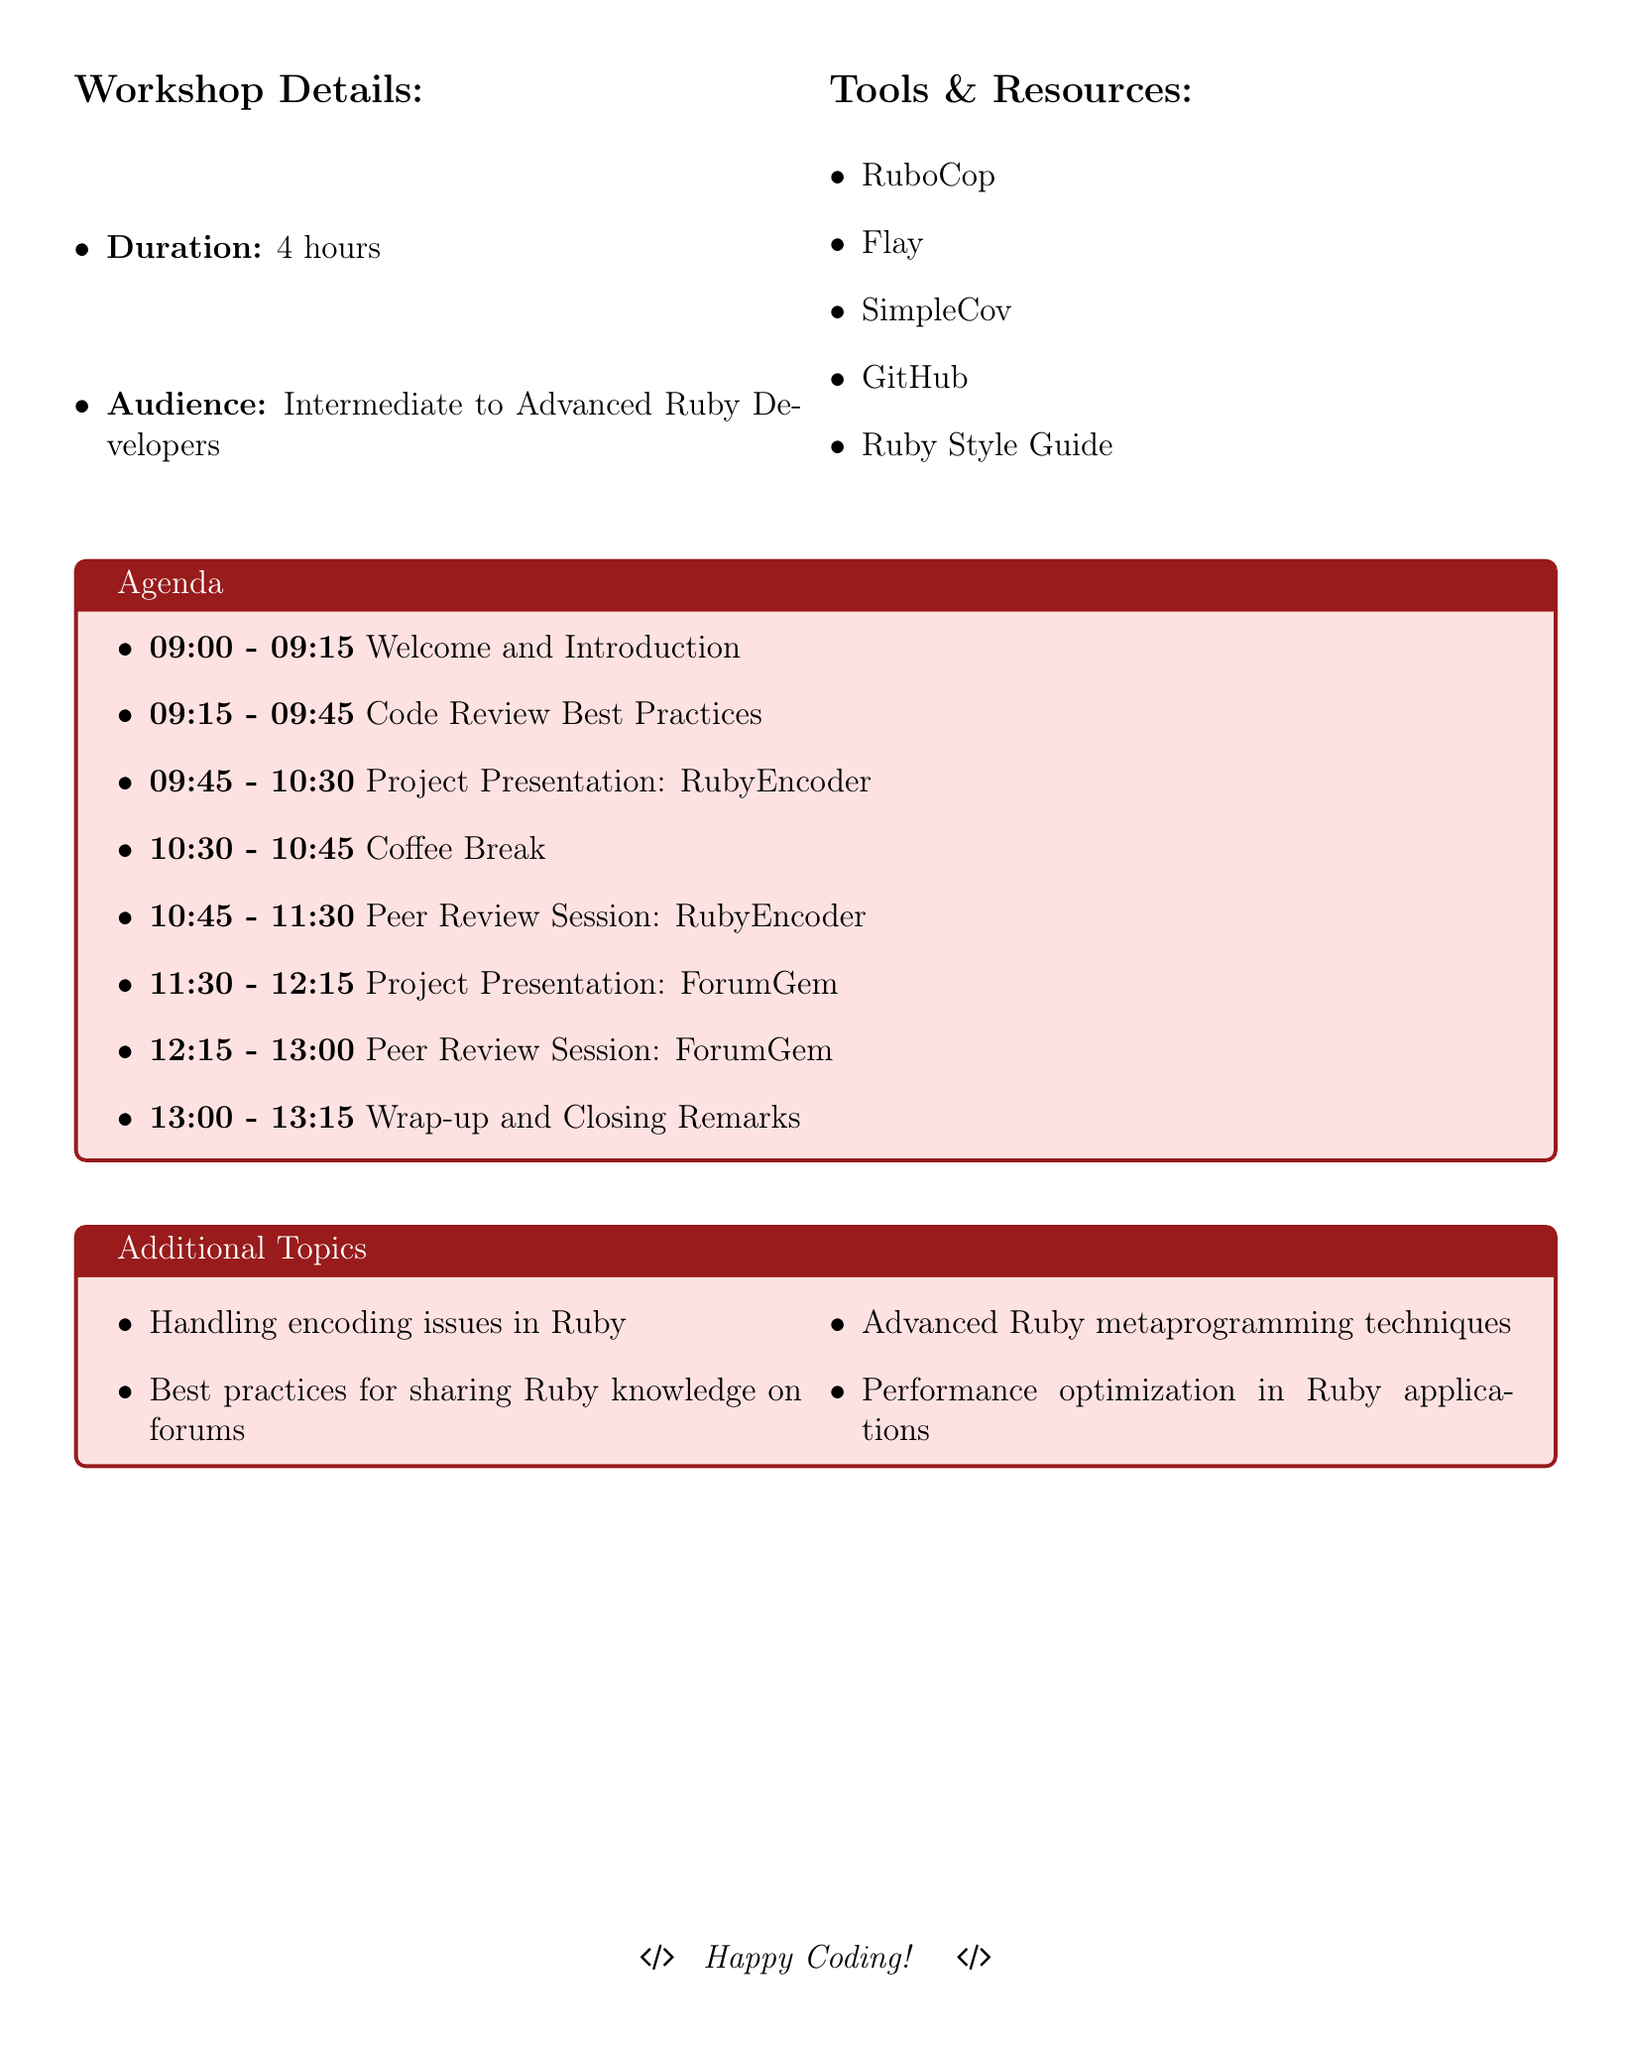What is the duration of the workshop? The duration of the workshop is specified in the document as a key detail for participants.
Answer: 4 hours Who is the target audience for this workshop? The document identifies the intended audience type, indicating the level of expertise expected.
Answer: Intermediate to Advanced Ruby Developers What time does the coffee break start? The coffee break's start time is listed within the agenda items, providing a specific time for attendees.
Answer: 10:30 How long is the Peer Review Session for RubyEncoder? The duration of each peer review session is listed, providing essential time management information.
Answer: 45 minutes What is one of the tools mentioned for code review? The document includes a list of tools and resources that are relevant to the workshop, highlighting important ones for participants.
Answer: RuboCop What is the last item on the agenda? The last item in the agenda outlines the final segment of the workshop, closing the session for attendees.
Answer: Wrap-up and Closing Remarks Which project is presented first? The order of project presentations is clearly stated, giving attendees insight into the flow of the agenda.
Answer: RubyEncoder What is one additional topic covered in the workshop? The document lists additional topics, providing insights into the depth of the workshop content.
Answer: Handling encoding issues in Ruby How many peer review sessions are planned? The document enumerates the number of peer review sessions to be conducted during the workshop.
Answer: 2 